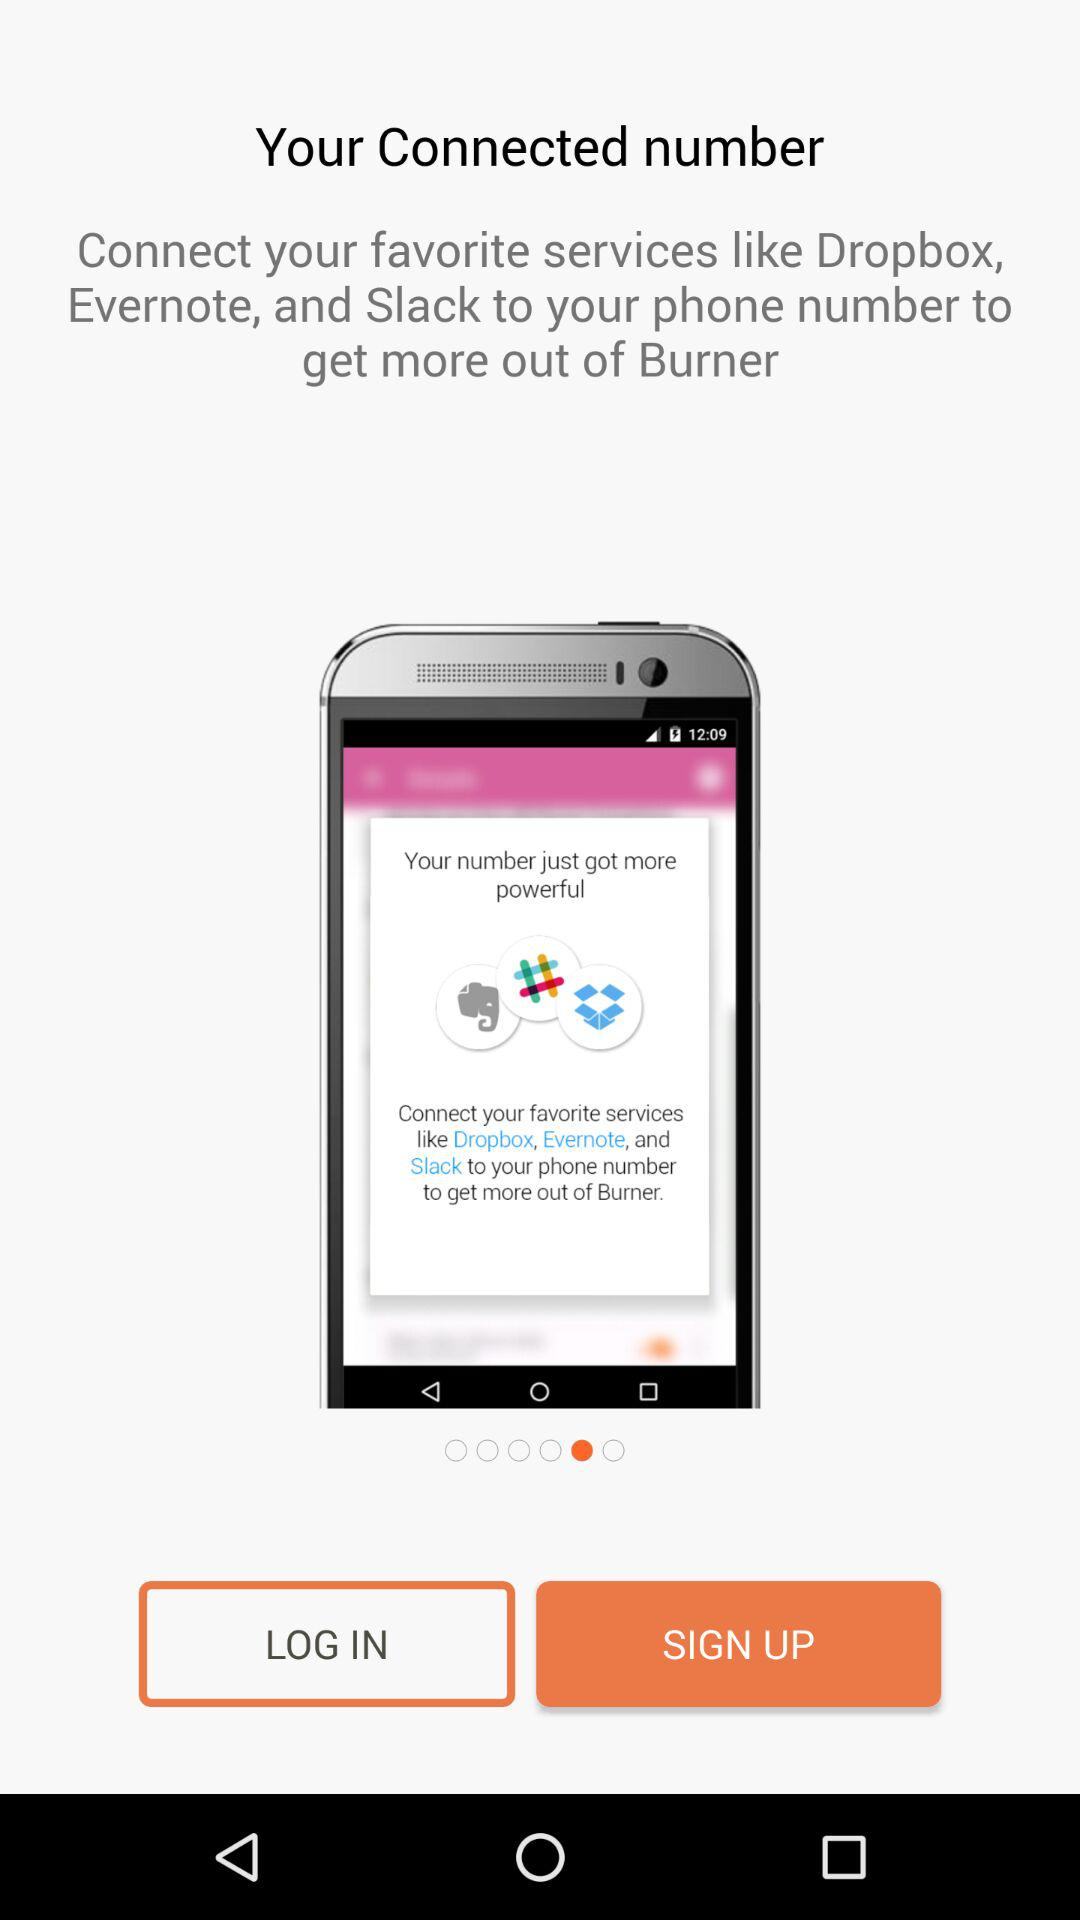What is the application name? The application name is "Burner". 